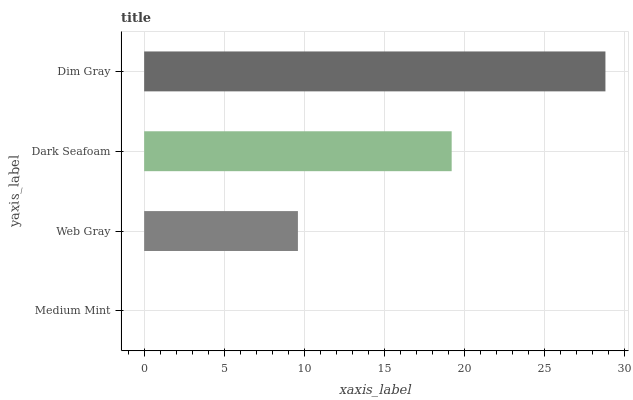Is Medium Mint the minimum?
Answer yes or no. Yes. Is Dim Gray the maximum?
Answer yes or no. Yes. Is Web Gray the minimum?
Answer yes or no. No. Is Web Gray the maximum?
Answer yes or no. No. Is Web Gray greater than Medium Mint?
Answer yes or no. Yes. Is Medium Mint less than Web Gray?
Answer yes or no. Yes. Is Medium Mint greater than Web Gray?
Answer yes or no. No. Is Web Gray less than Medium Mint?
Answer yes or no. No. Is Dark Seafoam the high median?
Answer yes or no. Yes. Is Web Gray the low median?
Answer yes or no. Yes. Is Web Gray the high median?
Answer yes or no. No. Is Dim Gray the low median?
Answer yes or no. No. 